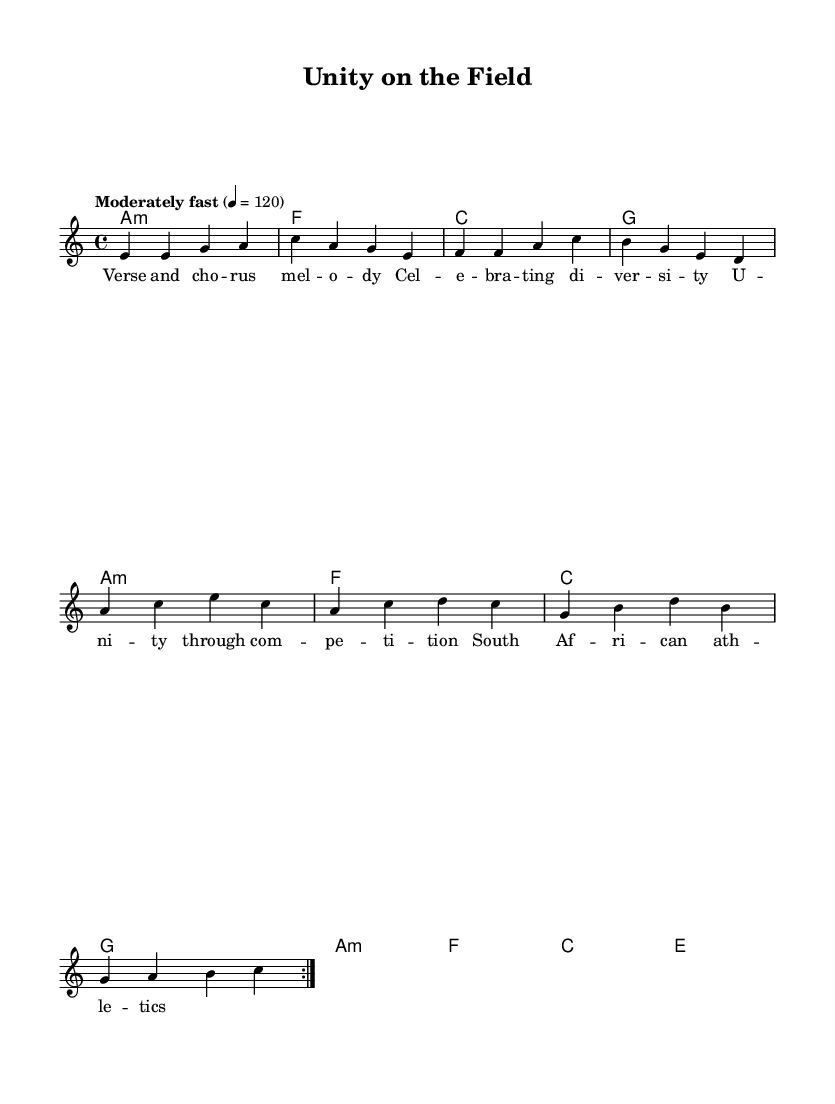What is the key signature of this music? The key signature is A minor, indicated by the absence of sharps or flats. The presence of the 'a' in the scale indicates the key.
Answer: A minor What is the time signature of this music? The time signature is 4/4, shown at the beginning of the score and indicating four beats per measure.
Answer: 4/4 What is the tempo marking for this piece? The tempo marking states "Moderately fast" with a metronome indication of 120 beats per minute, which guides the speed of the performance.
Answer: Moderately fast How many verses are indicated in the lyrics? The sheet music consists of a single verse, as evident from the lyrical layout under the melody without repeat markings for additional verses.
Answer: One What is the primary theme expressed in the lyrics? The lyrics explicitly mention "Celebrating diversity" and "Unity through competition," reflecting themes of unity and cultural diversity within the context of sports.
Answer: Celebrating diversity Which musical group is primarily represented according to the lyrics? The lyrics refer specifically to "South African athletics," suggesting a focus on athletics and sports within the South African context.
Answer: South African athletics Which chord is used at the beginning of the harmonies? The harmonies start with an A minor chord, as indicated by the notation in the chord mode section, specifically stated as "a1:m."
Answer: A minor 